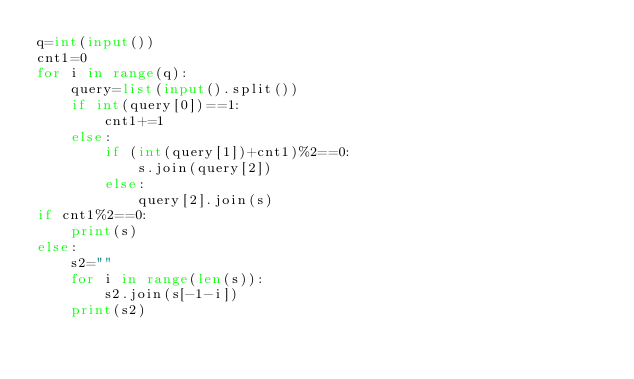<code> <loc_0><loc_0><loc_500><loc_500><_Python_>q=int(input())
cnt1=0
for i in range(q):
    query=list(input().split())
    if int(query[0])==1:
        cnt1+=1
    else:
        if (int(query[1])+cnt1)%2==0:
            s.join(query[2])
        else:
            query[2].join(s)
if cnt1%2==0:
    print(s)
else:
    s2=""
    for i in range(len(s)):
        s2.join(s[-1-i])
    print(s2)
</code> 